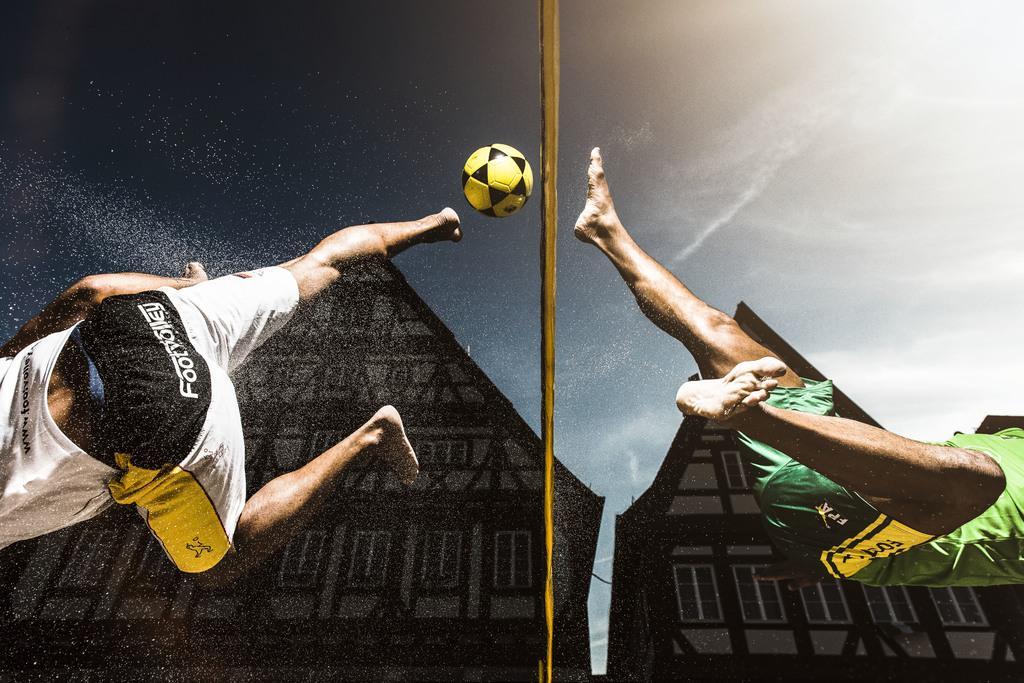In one or two sentences, can you explain what this image depicts? This picture seems to be an edited image. In the foreground we can see the two persons are in the air. In the center there is metal rod and a yellow color ball is in the air. In the background we can see the sky and the houses and we can see the windows of the houses. 